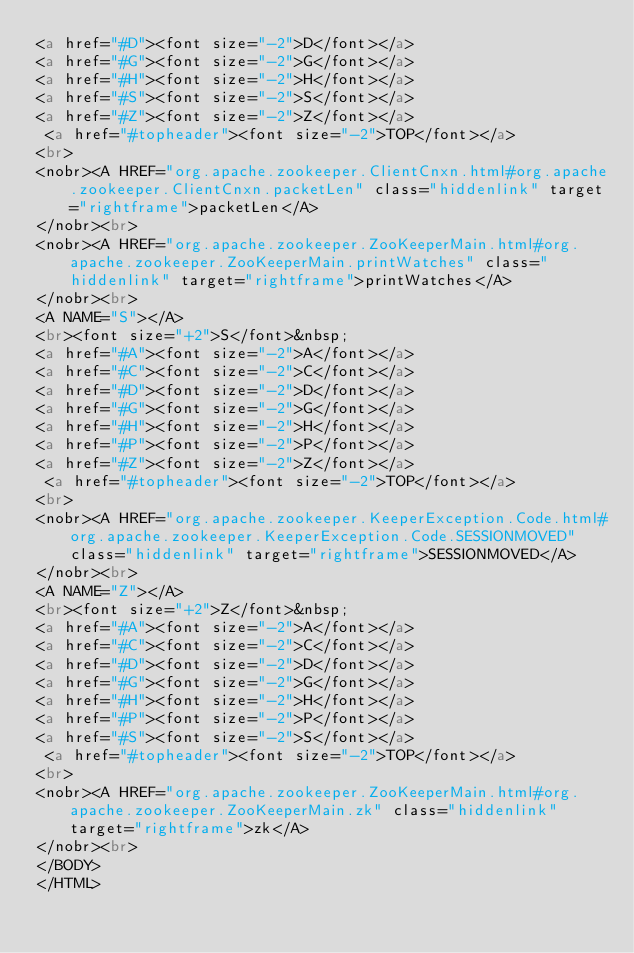Convert code to text. <code><loc_0><loc_0><loc_500><loc_500><_HTML_><a href="#D"><font size="-2">D</font></a> 
<a href="#G"><font size="-2">G</font></a> 
<a href="#H"><font size="-2">H</font></a> 
<a href="#S"><font size="-2">S</font></a> 
<a href="#Z"><font size="-2">Z</font></a> 
 <a href="#topheader"><font size="-2">TOP</font></a>
<br>
<nobr><A HREF="org.apache.zookeeper.ClientCnxn.html#org.apache.zookeeper.ClientCnxn.packetLen" class="hiddenlink" target="rightframe">packetLen</A>
</nobr><br>
<nobr><A HREF="org.apache.zookeeper.ZooKeeperMain.html#org.apache.zookeeper.ZooKeeperMain.printWatches" class="hiddenlink" target="rightframe">printWatches</A>
</nobr><br>
<A NAME="S"></A>
<br><font size="+2">S</font>&nbsp;
<a href="#A"><font size="-2">A</font></a> 
<a href="#C"><font size="-2">C</font></a> 
<a href="#D"><font size="-2">D</font></a> 
<a href="#G"><font size="-2">G</font></a> 
<a href="#H"><font size="-2">H</font></a> 
<a href="#P"><font size="-2">P</font></a> 
<a href="#Z"><font size="-2">Z</font></a> 
 <a href="#topheader"><font size="-2">TOP</font></a>
<br>
<nobr><A HREF="org.apache.zookeeper.KeeperException.Code.html#org.apache.zookeeper.KeeperException.Code.SESSIONMOVED" class="hiddenlink" target="rightframe">SESSIONMOVED</A>
</nobr><br>
<A NAME="Z"></A>
<br><font size="+2">Z</font>&nbsp;
<a href="#A"><font size="-2">A</font></a> 
<a href="#C"><font size="-2">C</font></a> 
<a href="#D"><font size="-2">D</font></a> 
<a href="#G"><font size="-2">G</font></a> 
<a href="#H"><font size="-2">H</font></a> 
<a href="#P"><font size="-2">P</font></a> 
<a href="#S"><font size="-2">S</font></a> 
 <a href="#topheader"><font size="-2">TOP</font></a>
<br>
<nobr><A HREF="org.apache.zookeeper.ZooKeeperMain.html#org.apache.zookeeper.ZooKeeperMain.zk" class="hiddenlink" target="rightframe">zk</A>
</nobr><br>
</BODY>
</HTML>
</code> 